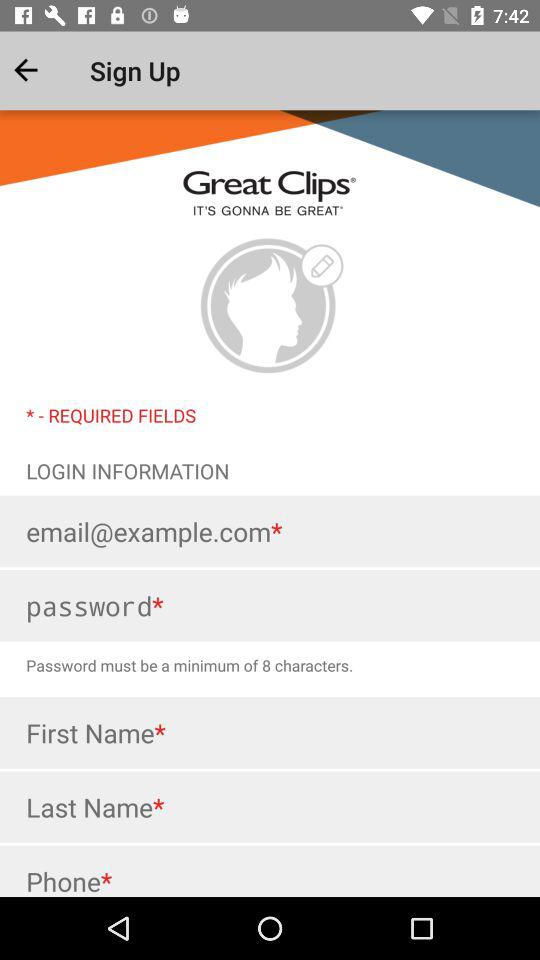What must be in the required password? In the required password, there must be a minimum of 8 characters. 